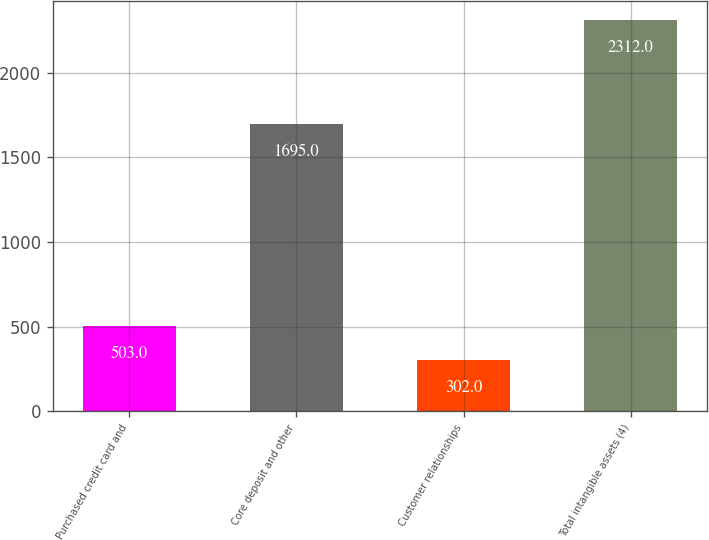Convert chart to OTSL. <chart><loc_0><loc_0><loc_500><loc_500><bar_chart><fcel>Purchased credit card and<fcel>Core deposit and other<fcel>Customer relationships<fcel>Total intangible assets (4)<nl><fcel>503<fcel>1695<fcel>302<fcel>2312<nl></chart> 